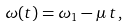Convert formula to latex. <formula><loc_0><loc_0><loc_500><loc_500>\omega ( t ) = \omega _ { 1 } - \mu \, t \, ,</formula> 